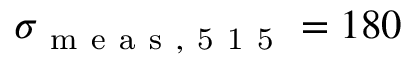Convert formula to latex. <formula><loc_0><loc_0><loc_500><loc_500>\sigma _ { m e a s , 5 1 5 } = 1 8 0</formula> 